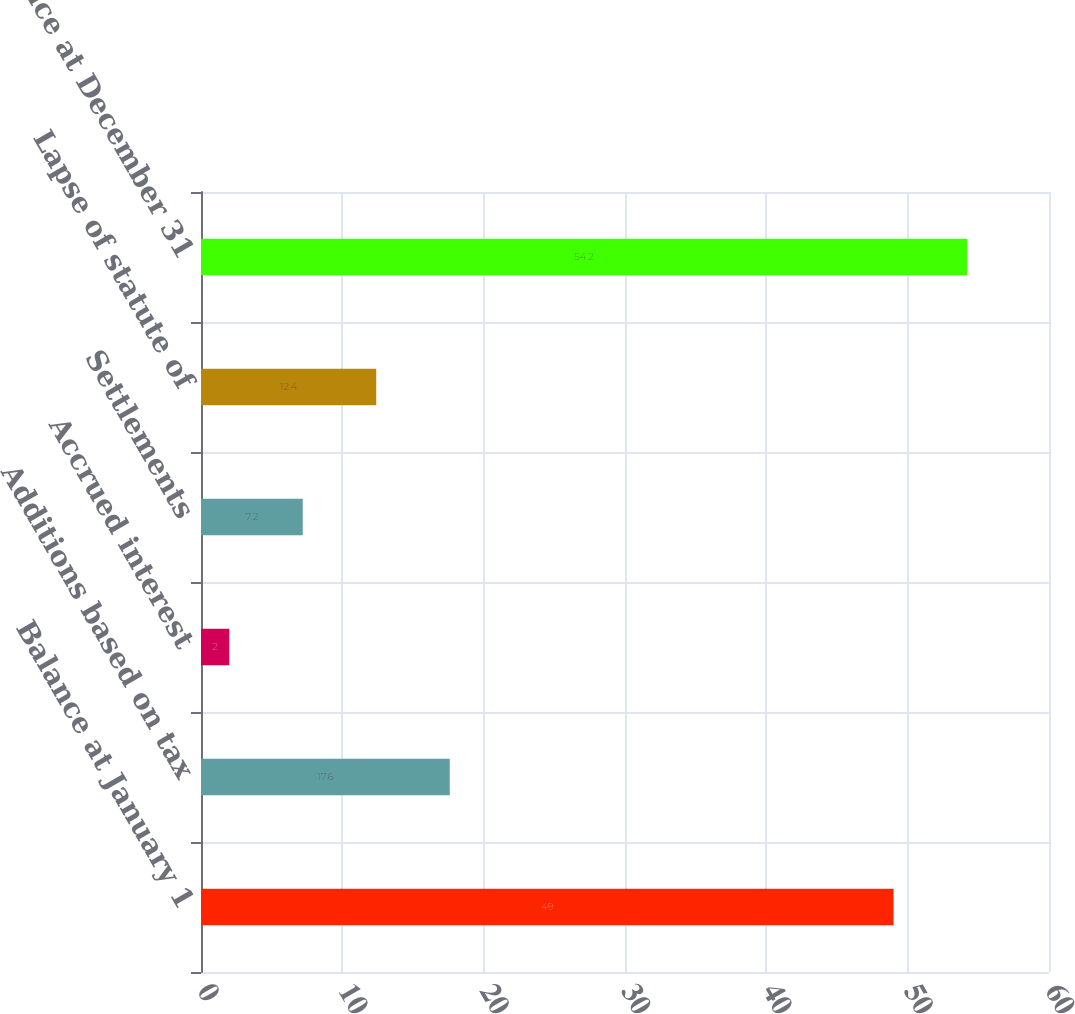<chart> <loc_0><loc_0><loc_500><loc_500><bar_chart><fcel>Balance at January 1<fcel>Additions based on tax<fcel>Accrued interest<fcel>Settlements<fcel>Lapse of statute of<fcel>Balance at December 31<nl><fcel>49<fcel>17.6<fcel>2<fcel>7.2<fcel>12.4<fcel>54.2<nl></chart> 